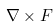Convert formula to latex. <formula><loc_0><loc_0><loc_500><loc_500>\nabla \times F</formula> 